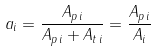Convert formula to latex. <formula><loc_0><loc_0><loc_500><loc_500>a _ { i } = \frac { A _ { p \, i } } { A _ { p \, i } + A _ { t \, i } } = \frac { A _ { p \, i } } { A _ { i } }</formula> 